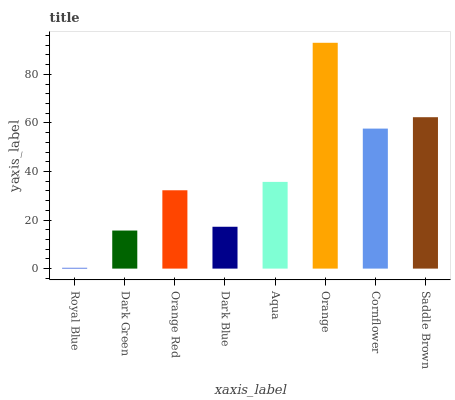Is Royal Blue the minimum?
Answer yes or no. Yes. Is Orange the maximum?
Answer yes or no. Yes. Is Dark Green the minimum?
Answer yes or no. No. Is Dark Green the maximum?
Answer yes or no. No. Is Dark Green greater than Royal Blue?
Answer yes or no. Yes. Is Royal Blue less than Dark Green?
Answer yes or no. Yes. Is Royal Blue greater than Dark Green?
Answer yes or no. No. Is Dark Green less than Royal Blue?
Answer yes or no. No. Is Aqua the high median?
Answer yes or no. Yes. Is Orange Red the low median?
Answer yes or no. Yes. Is Royal Blue the high median?
Answer yes or no. No. Is Saddle Brown the low median?
Answer yes or no. No. 